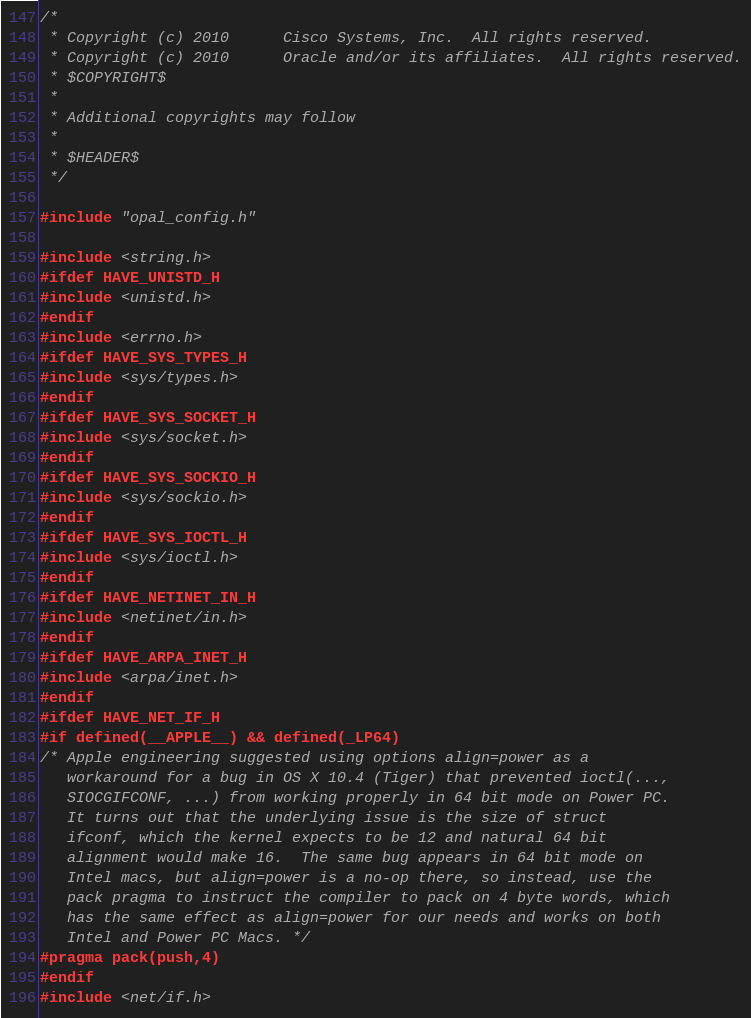Convert code to text. <code><loc_0><loc_0><loc_500><loc_500><_C_>/*
 * Copyright (c) 2010      Cisco Systems, Inc.  All rights reserved.
 * Copyright (c) 2010      Oracle and/or its affiliates.  All rights reserved.
 * $COPYRIGHT$
 *
 * Additional copyrights may follow
 *
 * $HEADER$
 */

#include "opal_config.h"

#include <string.h>
#ifdef HAVE_UNISTD_H
#include <unistd.h>
#endif
#include <errno.h>
#ifdef HAVE_SYS_TYPES_H
#include <sys/types.h>
#endif
#ifdef HAVE_SYS_SOCKET_H
#include <sys/socket.h>
#endif
#ifdef HAVE_SYS_SOCKIO_H
#include <sys/sockio.h>
#endif
#ifdef HAVE_SYS_IOCTL_H
#include <sys/ioctl.h>
#endif
#ifdef HAVE_NETINET_IN_H
#include <netinet/in.h>
#endif
#ifdef HAVE_ARPA_INET_H
#include <arpa/inet.h>
#endif
#ifdef HAVE_NET_IF_H
#if defined(__APPLE__) && defined(_LP64)
/* Apple engineering suggested using options align=power as a
   workaround for a bug in OS X 10.4 (Tiger) that prevented ioctl(...,
   SIOCGIFCONF, ...) from working properly in 64 bit mode on Power PC.
   It turns out that the underlying issue is the size of struct
   ifconf, which the kernel expects to be 12 and natural 64 bit
   alignment would make 16.  The same bug appears in 64 bit mode on
   Intel macs, but align=power is a no-op there, so instead, use the
   pack pragma to instruct the compiler to pack on 4 byte words, which
   has the same effect as align=power for our needs and works on both
   Intel and Power PC Macs. */
#pragma pack(push,4)
#endif
#include <net/if.h></code> 